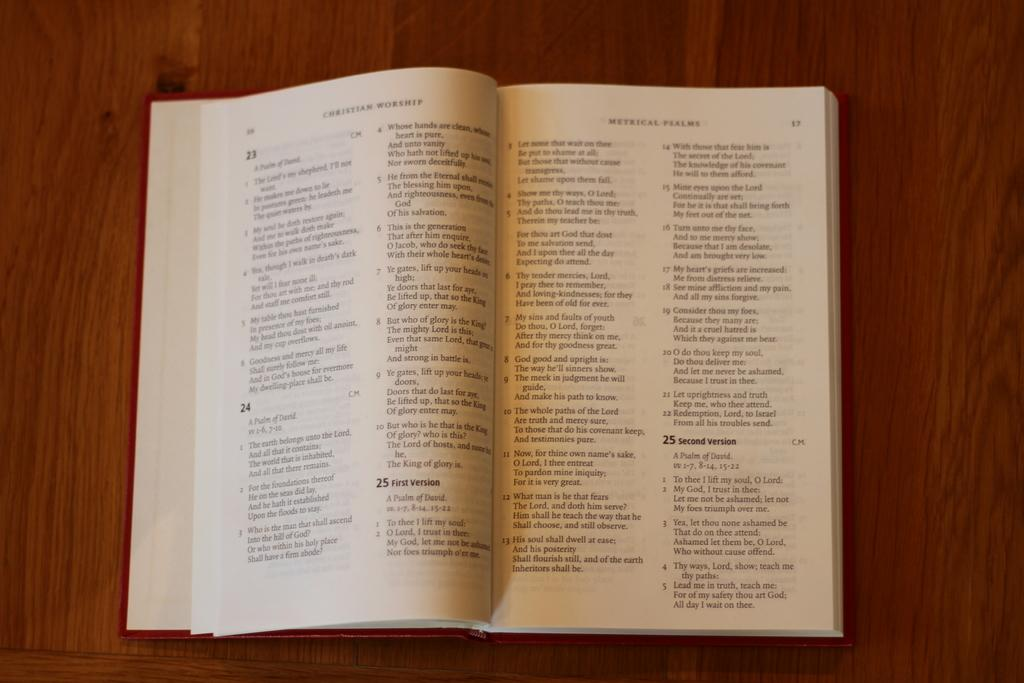<image>
Share a concise interpretation of the image provided. the number 25 is on the white page of the book 